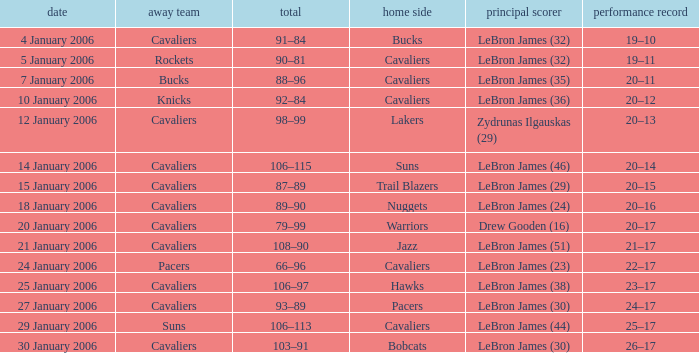Could you parse the entire table? {'header': ['date', 'away team', 'total', 'home side', 'principal scorer', 'performance record'], 'rows': [['4 January 2006', 'Cavaliers', '91–84', 'Bucks', 'LeBron James (32)', '19–10'], ['5 January 2006', 'Rockets', '90–81', 'Cavaliers', 'LeBron James (32)', '19–11'], ['7 January 2006', 'Bucks', '88–96', 'Cavaliers', 'LeBron James (35)', '20–11'], ['10 January 2006', 'Knicks', '92–84', 'Cavaliers', 'LeBron James (36)', '20–12'], ['12 January 2006', 'Cavaliers', '98–99', 'Lakers', 'Zydrunas Ilgauskas (29)', '20–13'], ['14 January 2006', 'Cavaliers', '106–115', 'Suns', 'LeBron James (46)', '20–14'], ['15 January 2006', 'Cavaliers', '87–89', 'Trail Blazers', 'LeBron James (29)', '20–15'], ['18 January 2006', 'Cavaliers', '89–90', 'Nuggets', 'LeBron James (24)', '20–16'], ['20 January 2006', 'Cavaliers', '79–99', 'Warriors', 'Drew Gooden (16)', '20–17'], ['21 January 2006', 'Cavaliers', '108–90', 'Jazz', 'LeBron James (51)', '21–17'], ['24 January 2006', 'Pacers', '66–96', 'Cavaliers', 'LeBron James (23)', '22–17'], ['25 January 2006', 'Cavaliers', '106–97', 'Hawks', 'LeBron James (38)', '23–17'], ['27 January 2006', 'Cavaliers', '93–89', 'Pacers', 'LeBron James (30)', '24–17'], ['29 January 2006', 'Suns', '106–113', 'Cavaliers', 'LeBron James (44)', '25–17'], ['30 January 2006', 'Cavaliers', '103–91', 'Bobcats', 'LeBron James (30)', '26–17']]} Who was the leading score in the game at the Warriors? Drew Gooden (16). 